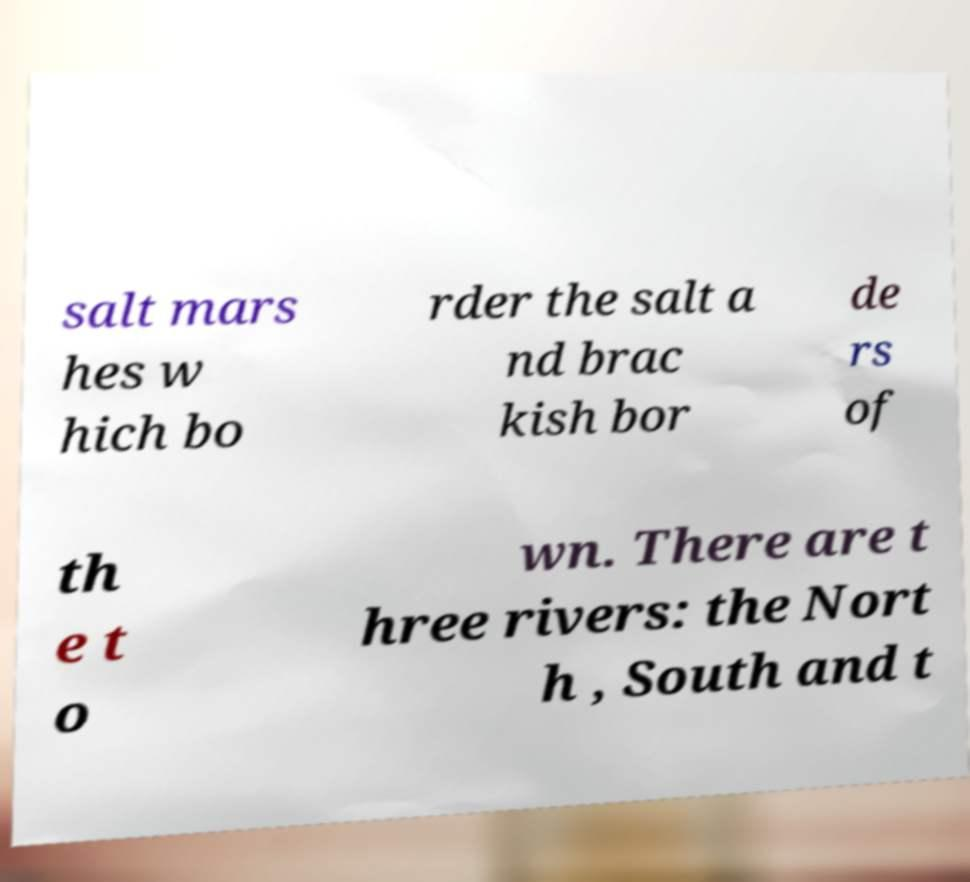Can you read and provide the text displayed in the image?This photo seems to have some interesting text. Can you extract and type it out for me? salt mars hes w hich bo rder the salt a nd brac kish bor de rs of th e t o wn. There are t hree rivers: the Nort h , South and t 